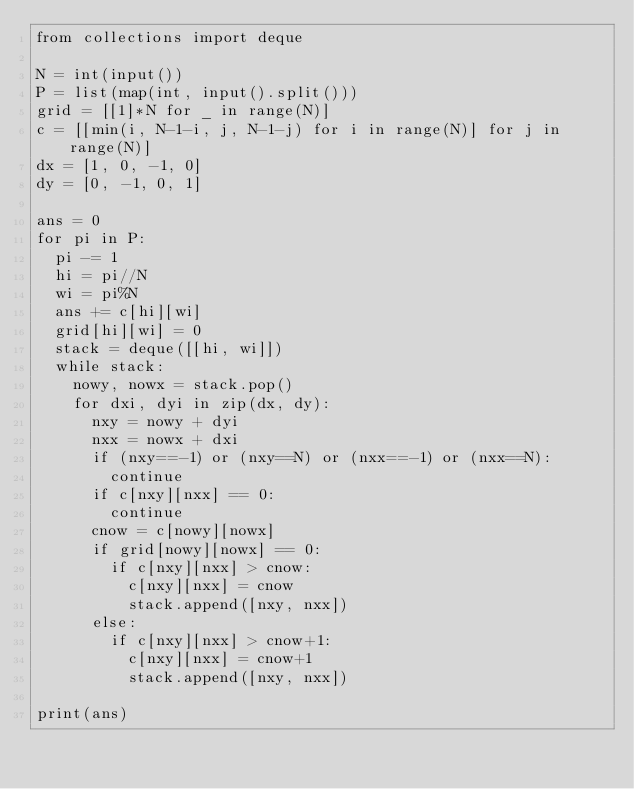Convert code to text. <code><loc_0><loc_0><loc_500><loc_500><_Python_>from collections import deque

N = int(input())
P = list(map(int, input().split()))
grid = [[1]*N for _ in range(N)]
c = [[min(i, N-1-i, j, N-1-j) for i in range(N)] for j in range(N)]
dx = [1, 0, -1, 0]
dy = [0, -1, 0, 1]

ans = 0
for pi in P:
  pi -= 1
  hi = pi//N
  wi = pi%N
  ans += c[hi][wi]
  grid[hi][wi] = 0
  stack = deque([[hi, wi]])
  while stack:
    nowy, nowx = stack.pop()
    for dxi, dyi in zip(dx, dy):
      nxy = nowy + dyi
      nxx = nowx + dxi
      if (nxy==-1) or (nxy==N) or (nxx==-1) or (nxx==N):
        continue
      if c[nxy][nxx] == 0:
        continue
      cnow = c[nowy][nowx]
      if grid[nowy][nowx] == 0:
        if c[nxy][nxx] > cnow:
          c[nxy][nxx] = cnow
          stack.append([nxy, nxx])
      else:
        if c[nxy][nxx] > cnow+1:
          c[nxy][nxx] = cnow+1
          stack.append([nxy, nxx])

print(ans)
</code> 